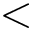Convert formula to latex. <formula><loc_0><loc_0><loc_500><loc_500><</formula> 